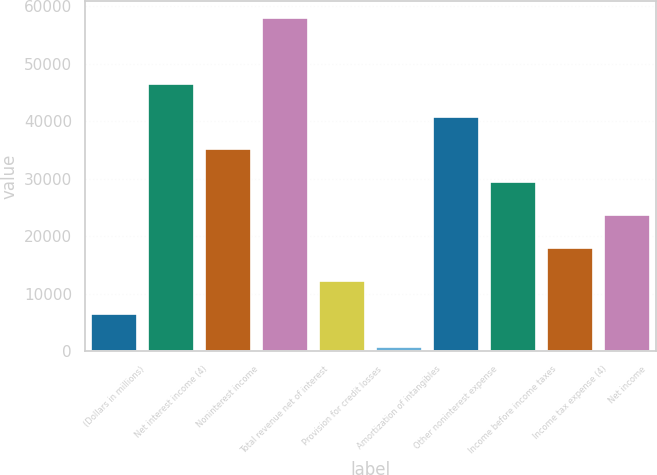Convert chart. <chart><loc_0><loc_0><loc_500><loc_500><bar_chart><fcel>(Dollars in millions)<fcel>Net interest income (4)<fcel>Noninterest income<fcel>Total revenue net of interest<fcel>Provision for credit losses<fcel>Amortization of intangibles<fcel>Other noninterest expense<fcel>Income before income taxes<fcel>Income tax expense (4)<fcel>Net income<nl><fcel>6528.8<fcel>46567.4<fcel>35127.8<fcel>58007<fcel>12248.6<fcel>809<fcel>40847.6<fcel>29408<fcel>17968.4<fcel>23688.2<nl></chart> 